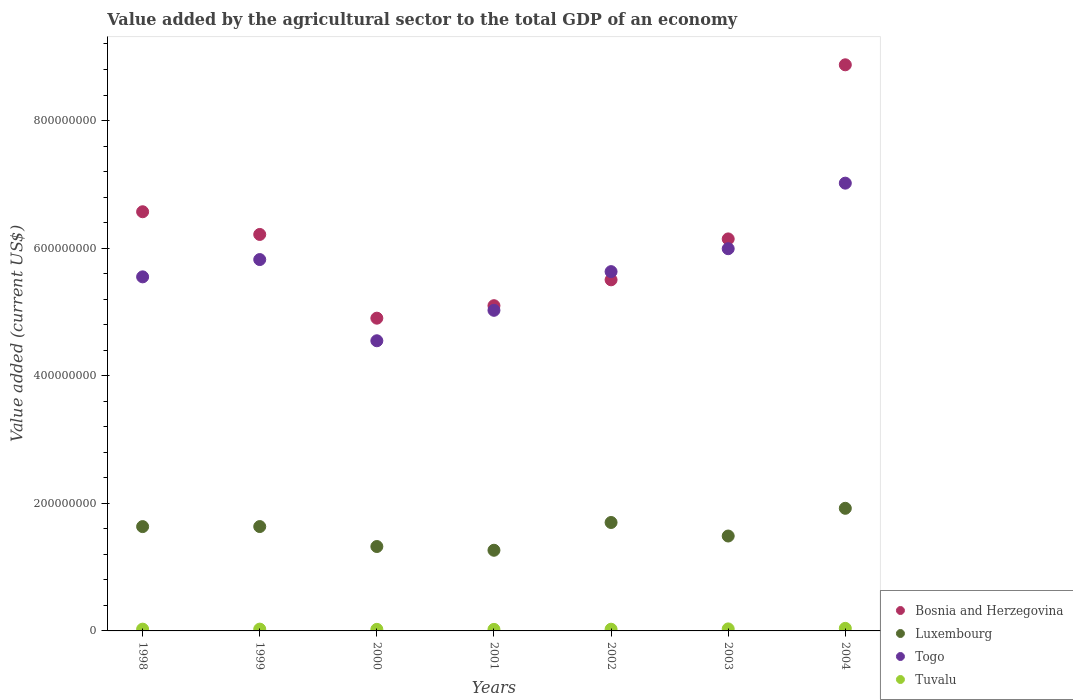What is the value added by the agricultural sector to the total GDP in Luxembourg in 2001?
Keep it short and to the point. 1.26e+08. Across all years, what is the maximum value added by the agricultural sector to the total GDP in Luxembourg?
Provide a short and direct response. 1.92e+08. Across all years, what is the minimum value added by the agricultural sector to the total GDP in Bosnia and Herzegovina?
Keep it short and to the point. 4.90e+08. In which year was the value added by the agricultural sector to the total GDP in Bosnia and Herzegovina maximum?
Provide a succinct answer. 2004. In which year was the value added by the agricultural sector to the total GDP in Bosnia and Herzegovina minimum?
Keep it short and to the point. 2000. What is the total value added by the agricultural sector to the total GDP in Bosnia and Herzegovina in the graph?
Make the answer very short. 4.33e+09. What is the difference between the value added by the agricultural sector to the total GDP in Bosnia and Herzegovina in 1998 and that in 1999?
Your response must be concise. 3.56e+07. What is the difference between the value added by the agricultural sector to the total GDP in Luxembourg in 1998 and the value added by the agricultural sector to the total GDP in Togo in 2002?
Give a very brief answer. -4.00e+08. What is the average value added by the agricultural sector to the total GDP in Tuvalu per year?
Give a very brief answer. 2.91e+06. In the year 2004, what is the difference between the value added by the agricultural sector to the total GDP in Tuvalu and value added by the agricultural sector to the total GDP in Bosnia and Herzegovina?
Your response must be concise. -8.83e+08. What is the ratio of the value added by the agricultural sector to the total GDP in Tuvalu in 1999 to that in 2001?
Offer a terse response. 1.17. Is the value added by the agricultural sector to the total GDP in Luxembourg in 1999 less than that in 2001?
Provide a short and direct response. No. Is the difference between the value added by the agricultural sector to the total GDP in Tuvalu in 1999 and 2000 greater than the difference between the value added by the agricultural sector to the total GDP in Bosnia and Herzegovina in 1999 and 2000?
Ensure brevity in your answer.  No. What is the difference between the highest and the second highest value added by the agricultural sector to the total GDP in Tuvalu?
Offer a very short reply. 8.54e+05. What is the difference between the highest and the lowest value added by the agricultural sector to the total GDP in Luxembourg?
Your answer should be compact. 6.58e+07. In how many years, is the value added by the agricultural sector to the total GDP in Bosnia and Herzegovina greater than the average value added by the agricultural sector to the total GDP in Bosnia and Herzegovina taken over all years?
Provide a short and direct response. 3. Is the sum of the value added by the agricultural sector to the total GDP in Luxembourg in 1999 and 2000 greater than the maximum value added by the agricultural sector to the total GDP in Togo across all years?
Your answer should be very brief. No. Is it the case that in every year, the sum of the value added by the agricultural sector to the total GDP in Togo and value added by the agricultural sector to the total GDP in Luxembourg  is greater than the sum of value added by the agricultural sector to the total GDP in Bosnia and Herzegovina and value added by the agricultural sector to the total GDP in Tuvalu?
Keep it short and to the point. No. Is it the case that in every year, the sum of the value added by the agricultural sector to the total GDP in Bosnia and Herzegovina and value added by the agricultural sector to the total GDP in Tuvalu  is greater than the value added by the agricultural sector to the total GDP in Luxembourg?
Ensure brevity in your answer.  Yes. Is the value added by the agricultural sector to the total GDP in Tuvalu strictly greater than the value added by the agricultural sector to the total GDP in Togo over the years?
Your answer should be very brief. No. Is the value added by the agricultural sector to the total GDP in Tuvalu strictly less than the value added by the agricultural sector to the total GDP in Bosnia and Herzegovina over the years?
Your response must be concise. Yes. How many dotlines are there?
Your response must be concise. 4. How many years are there in the graph?
Your answer should be very brief. 7. What is the difference between two consecutive major ticks on the Y-axis?
Give a very brief answer. 2.00e+08. Are the values on the major ticks of Y-axis written in scientific E-notation?
Make the answer very short. No. Does the graph contain grids?
Provide a succinct answer. No. How are the legend labels stacked?
Provide a succinct answer. Vertical. What is the title of the graph?
Give a very brief answer. Value added by the agricultural sector to the total GDP of an economy. Does "Cabo Verde" appear as one of the legend labels in the graph?
Your answer should be very brief. No. What is the label or title of the Y-axis?
Your answer should be compact. Value added (current US$). What is the Value added (current US$) in Bosnia and Herzegovina in 1998?
Give a very brief answer. 6.57e+08. What is the Value added (current US$) in Luxembourg in 1998?
Provide a succinct answer. 1.64e+08. What is the Value added (current US$) of Togo in 1998?
Offer a very short reply. 5.55e+08. What is the Value added (current US$) of Tuvalu in 1998?
Provide a succinct answer. 2.78e+06. What is the Value added (current US$) in Bosnia and Herzegovina in 1999?
Ensure brevity in your answer.  6.21e+08. What is the Value added (current US$) of Luxembourg in 1999?
Your answer should be very brief. 1.64e+08. What is the Value added (current US$) in Togo in 1999?
Your answer should be very brief. 5.82e+08. What is the Value added (current US$) in Tuvalu in 1999?
Your answer should be very brief. 2.83e+06. What is the Value added (current US$) of Bosnia and Herzegovina in 2000?
Offer a very short reply. 4.90e+08. What is the Value added (current US$) in Luxembourg in 2000?
Your answer should be compact. 1.32e+08. What is the Value added (current US$) of Togo in 2000?
Provide a succinct answer. 4.55e+08. What is the Value added (current US$) of Tuvalu in 2000?
Your answer should be compact. 2.46e+06. What is the Value added (current US$) of Bosnia and Herzegovina in 2001?
Offer a terse response. 5.10e+08. What is the Value added (current US$) in Luxembourg in 2001?
Provide a succinct answer. 1.26e+08. What is the Value added (current US$) of Togo in 2001?
Make the answer very short. 5.03e+08. What is the Value added (current US$) in Tuvalu in 2001?
Keep it short and to the point. 2.42e+06. What is the Value added (current US$) in Bosnia and Herzegovina in 2002?
Offer a terse response. 5.50e+08. What is the Value added (current US$) of Luxembourg in 2002?
Offer a very short reply. 1.70e+08. What is the Value added (current US$) in Togo in 2002?
Give a very brief answer. 5.63e+08. What is the Value added (current US$) of Tuvalu in 2002?
Make the answer very short. 2.69e+06. What is the Value added (current US$) in Bosnia and Herzegovina in 2003?
Your response must be concise. 6.14e+08. What is the Value added (current US$) in Luxembourg in 2003?
Ensure brevity in your answer.  1.49e+08. What is the Value added (current US$) in Togo in 2003?
Ensure brevity in your answer.  5.99e+08. What is the Value added (current US$) in Tuvalu in 2003?
Your answer should be very brief. 3.17e+06. What is the Value added (current US$) in Bosnia and Herzegovina in 2004?
Provide a succinct answer. 8.87e+08. What is the Value added (current US$) in Luxembourg in 2004?
Offer a very short reply. 1.92e+08. What is the Value added (current US$) of Togo in 2004?
Ensure brevity in your answer.  7.02e+08. What is the Value added (current US$) in Tuvalu in 2004?
Provide a short and direct response. 4.02e+06. Across all years, what is the maximum Value added (current US$) of Bosnia and Herzegovina?
Provide a succinct answer. 8.87e+08. Across all years, what is the maximum Value added (current US$) of Luxembourg?
Offer a very short reply. 1.92e+08. Across all years, what is the maximum Value added (current US$) of Togo?
Offer a very short reply. 7.02e+08. Across all years, what is the maximum Value added (current US$) in Tuvalu?
Provide a short and direct response. 4.02e+06. Across all years, what is the minimum Value added (current US$) of Bosnia and Herzegovina?
Ensure brevity in your answer.  4.90e+08. Across all years, what is the minimum Value added (current US$) in Luxembourg?
Your answer should be very brief. 1.26e+08. Across all years, what is the minimum Value added (current US$) in Togo?
Offer a very short reply. 4.55e+08. Across all years, what is the minimum Value added (current US$) of Tuvalu?
Offer a very short reply. 2.42e+06. What is the total Value added (current US$) in Bosnia and Herzegovina in the graph?
Keep it short and to the point. 4.33e+09. What is the total Value added (current US$) of Luxembourg in the graph?
Provide a short and direct response. 1.10e+09. What is the total Value added (current US$) in Togo in the graph?
Your answer should be very brief. 3.96e+09. What is the total Value added (current US$) in Tuvalu in the graph?
Provide a succinct answer. 2.04e+07. What is the difference between the Value added (current US$) of Bosnia and Herzegovina in 1998 and that in 1999?
Your response must be concise. 3.56e+07. What is the difference between the Value added (current US$) of Luxembourg in 1998 and that in 1999?
Offer a very short reply. -7.59e+04. What is the difference between the Value added (current US$) in Togo in 1998 and that in 1999?
Provide a succinct answer. -2.71e+07. What is the difference between the Value added (current US$) of Tuvalu in 1998 and that in 1999?
Provide a short and direct response. -5.75e+04. What is the difference between the Value added (current US$) of Bosnia and Herzegovina in 1998 and that in 2000?
Offer a very short reply. 1.67e+08. What is the difference between the Value added (current US$) in Luxembourg in 1998 and that in 2000?
Your answer should be compact. 3.12e+07. What is the difference between the Value added (current US$) in Togo in 1998 and that in 2000?
Offer a terse response. 1.00e+08. What is the difference between the Value added (current US$) in Tuvalu in 1998 and that in 2000?
Ensure brevity in your answer.  3.14e+05. What is the difference between the Value added (current US$) of Bosnia and Herzegovina in 1998 and that in 2001?
Ensure brevity in your answer.  1.47e+08. What is the difference between the Value added (current US$) in Luxembourg in 1998 and that in 2001?
Your answer should be very brief. 3.71e+07. What is the difference between the Value added (current US$) in Togo in 1998 and that in 2001?
Give a very brief answer. 5.24e+07. What is the difference between the Value added (current US$) of Tuvalu in 1998 and that in 2001?
Offer a terse response. 3.61e+05. What is the difference between the Value added (current US$) in Bosnia and Herzegovina in 1998 and that in 2002?
Your answer should be very brief. 1.07e+08. What is the difference between the Value added (current US$) of Luxembourg in 1998 and that in 2002?
Ensure brevity in your answer.  -6.45e+06. What is the difference between the Value added (current US$) in Togo in 1998 and that in 2002?
Keep it short and to the point. -8.19e+06. What is the difference between the Value added (current US$) in Tuvalu in 1998 and that in 2002?
Keep it short and to the point. 9.21e+04. What is the difference between the Value added (current US$) in Bosnia and Herzegovina in 1998 and that in 2003?
Offer a very short reply. 4.26e+07. What is the difference between the Value added (current US$) in Luxembourg in 1998 and that in 2003?
Offer a terse response. 1.48e+07. What is the difference between the Value added (current US$) in Togo in 1998 and that in 2003?
Ensure brevity in your answer.  -4.41e+07. What is the difference between the Value added (current US$) in Tuvalu in 1998 and that in 2003?
Keep it short and to the point. -3.92e+05. What is the difference between the Value added (current US$) of Bosnia and Herzegovina in 1998 and that in 2004?
Provide a succinct answer. -2.30e+08. What is the difference between the Value added (current US$) in Luxembourg in 1998 and that in 2004?
Your response must be concise. -2.87e+07. What is the difference between the Value added (current US$) in Togo in 1998 and that in 2004?
Provide a short and direct response. -1.47e+08. What is the difference between the Value added (current US$) of Tuvalu in 1998 and that in 2004?
Make the answer very short. -1.25e+06. What is the difference between the Value added (current US$) of Bosnia and Herzegovina in 1999 and that in 2000?
Offer a terse response. 1.31e+08. What is the difference between the Value added (current US$) of Luxembourg in 1999 and that in 2000?
Offer a very short reply. 3.13e+07. What is the difference between the Value added (current US$) of Togo in 1999 and that in 2000?
Make the answer very short. 1.27e+08. What is the difference between the Value added (current US$) in Tuvalu in 1999 and that in 2000?
Offer a terse response. 3.72e+05. What is the difference between the Value added (current US$) in Bosnia and Herzegovina in 1999 and that in 2001?
Offer a very short reply. 1.12e+08. What is the difference between the Value added (current US$) in Luxembourg in 1999 and that in 2001?
Offer a terse response. 3.71e+07. What is the difference between the Value added (current US$) of Togo in 1999 and that in 2001?
Make the answer very short. 7.96e+07. What is the difference between the Value added (current US$) of Tuvalu in 1999 and that in 2001?
Offer a very short reply. 4.18e+05. What is the difference between the Value added (current US$) of Bosnia and Herzegovina in 1999 and that in 2002?
Ensure brevity in your answer.  7.11e+07. What is the difference between the Value added (current US$) of Luxembourg in 1999 and that in 2002?
Offer a very short reply. -6.37e+06. What is the difference between the Value added (current US$) of Togo in 1999 and that in 2002?
Provide a succinct answer. 1.89e+07. What is the difference between the Value added (current US$) of Tuvalu in 1999 and that in 2002?
Offer a very short reply. 1.50e+05. What is the difference between the Value added (current US$) in Bosnia and Herzegovina in 1999 and that in 2003?
Give a very brief answer. 7.01e+06. What is the difference between the Value added (current US$) of Luxembourg in 1999 and that in 2003?
Provide a short and direct response. 1.48e+07. What is the difference between the Value added (current US$) in Togo in 1999 and that in 2003?
Give a very brief answer. -1.70e+07. What is the difference between the Value added (current US$) in Tuvalu in 1999 and that in 2003?
Offer a terse response. -3.35e+05. What is the difference between the Value added (current US$) in Bosnia and Herzegovina in 1999 and that in 2004?
Keep it short and to the point. -2.66e+08. What is the difference between the Value added (current US$) in Luxembourg in 1999 and that in 2004?
Your answer should be compact. -2.86e+07. What is the difference between the Value added (current US$) of Togo in 1999 and that in 2004?
Provide a succinct answer. -1.20e+08. What is the difference between the Value added (current US$) in Tuvalu in 1999 and that in 2004?
Ensure brevity in your answer.  -1.19e+06. What is the difference between the Value added (current US$) in Bosnia and Herzegovina in 2000 and that in 2001?
Your answer should be compact. -1.96e+07. What is the difference between the Value added (current US$) of Luxembourg in 2000 and that in 2001?
Your answer should be very brief. 5.86e+06. What is the difference between the Value added (current US$) in Togo in 2000 and that in 2001?
Give a very brief answer. -4.77e+07. What is the difference between the Value added (current US$) in Tuvalu in 2000 and that in 2001?
Your response must be concise. 4.62e+04. What is the difference between the Value added (current US$) in Bosnia and Herzegovina in 2000 and that in 2002?
Provide a short and direct response. -6.01e+07. What is the difference between the Value added (current US$) of Luxembourg in 2000 and that in 2002?
Give a very brief answer. -3.77e+07. What is the difference between the Value added (current US$) in Togo in 2000 and that in 2002?
Your answer should be compact. -1.08e+08. What is the difference between the Value added (current US$) of Tuvalu in 2000 and that in 2002?
Ensure brevity in your answer.  -2.22e+05. What is the difference between the Value added (current US$) of Bosnia and Herzegovina in 2000 and that in 2003?
Offer a terse response. -1.24e+08. What is the difference between the Value added (current US$) in Luxembourg in 2000 and that in 2003?
Offer a very short reply. -1.65e+07. What is the difference between the Value added (current US$) in Togo in 2000 and that in 2003?
Provide a short and direct response. -1.44e+08. What is the difference between the Value added (current US$) in Tuvalu in 2000 and that in 2003?
Provide a short and direct response. -7.07e+05. What is the difference between the Value added (current US$) in Bosnia and Herzegovina in 2000 and that in 2004?
Your answer should be very brief. -3.97e+08. What is the difference between the Value added (current US$) of Luxembourg in 2000 and that in 2004?
Offer a very short reply. -5.99e+07. What is the difference between the Value added (current US$) of Togo in 2000 and that in 2004?
Offer a terse response. -2.47e+08. What is the difference between the Value added (current US$) of Tuvalu in 2000 and that in 2004?
Your answer should be very brief. -1.56e+06. What is the difference between the Value added (current US$) in Bosnia and Herzegovina in 2001 and that in 2002?
Offer a terse response. -4.05e+07. What is the difference between the Value added (current US$) in Luxembourg in 2001 and that in 2002?
Your response must be concise. -4.35e+07. What is the difference between the Value added (current US$) in Togo in 2001 and that in 2002?
Ensure brevity in your answer.  -6.06e+07. What is the difference between the Value added (current US$) of Tuvalu in 2001 and that in 2002?
Make the answer very short. -2.68e+05. What is the difference between the Value added (current US$) of Bosnia and Herzegovina in 2001 and that in 2003?
Provide a short and direct response. -1.05e+08. What is the difference between the Value added (current US$) of Luxembourg in 2001 and that in 2003?
Ensure brevity in your answer.  -2.23e+07. What is the difference between the Value added (current US$) of Togo in 2001 and that in 2003?
Your answer should be compact. -9.66e+07. What is the difference between the Value added (current US$) in Tuvalu in 2001 and that in 2003?
Provide a succinct answer. -7.53e+05. What is the difference between the Value added (current US$) in Bosnia and Herzegovina in 2001 and that in 2004?
Your answer should be compact. -3.78e+08. What is the difference between the Value added (current US$) of Luxembourg in 2001 and that in 2004?
Provide a succinct answer. -6.58e+07. What is the difference between the Value added (current US$) of Togo in 2001 and that in 2004?
Your response must be concise. -1.99e+08. What is the difference between the Value added (current US$) of Tuvalu in 2001 and that in 2004?
Your answer should be very brief. -1.61e+06. What is the difference between the Value added (current US$) of Bosnia and Herzegovina in 2002 and that in 2003?
Make the answer very short. -6.41e+07. What is the difference between the Value added (current US$) of Luxembourg in 2002 and that in 2003?
Offer a terse response. 2.12e+07. What is the difference between the Value added (current US$) in Togo in 2002 and that in 2003?
Your answer should be very brief. -3.59e+07. What is the difference between the Value added (current US$) in Tuvalu in 2002 and that in 2003?
Make the answer very short. -4.84e+05. What is the difference between the Value added (current US$) of Bosnia and Herzegovina in 2002 and that in 2004?
Offer a terse response. -3.37e+08. What is the difference between the Value added (current US$) of Luxembourg in 2002 and that in 2004?
Make the answer very short. -2.22e+07. What is the difference between the Value added (current US$) of Togo in 2002 and that in 2004?
Your answer should be very brief. -1.39e+08. What is the difference between the Value added (current US$) of Tuvalu in 2002 and that in 2004?
Keep it short and to the point. -1.34e+06. What is the difference between the Value added (current US$) in Bosnia and Herzegovina in 2003 and that in 2004?
Give a very brief answer. -2.73e+08. What is the difference between the Value added (current US$) of Luxembourg in 2003 and that in 2004?
Provide a short and direct response. -4.34e+07. What is the difference between the Value added (current US$) of Togo in 2003 and that in 2004?
Offer a very short reply. -1.03e+08. What is the difference between the Value added (current US$) in Tuvalu in 2003 and that in 2004?
Make the answer very short. -8.54e+05. What is the difference between the Value added (current US$) of Bosnia and Herzegovina in 1998 and the Value added (current US$) of Luxembourg in 1999?
Give a very brief answer. 4.93e+08. What is the difference between the Value added (current US$) of Bosnia and Herzegovina in 1998 and the Value added (current US$) of Togo in 1999?
Keep it short and to the point. 7.49e+07. What is the difference between the Value added (current US$) in Bosnia and Herzegovina in 1998 and the Value added (current US$) in Tuvalu in 1999?
Keep it short and to the point. 6.54e+08. What is the difference between the Value added (current US$) in Luxembourg in 1998 and the Value added (current US$) in Togo in 1999?
Make the answer very short. -4.19e+08. What is the difference between the Value added (current US$) in Luxembourg in 1998 and the Value added (current US$) in Tuvalu in 1999?
Ensure brevity in your answer.  1.61e+08. What is the difference between the Value added (current US$) of Togo in 1998 and the Value added (current US$) of Tuvalu in 1999?
Provide a succinct answer. 5.52e+08. What is the difference between the Value added (current US$) of Bosnia and Herzegovina in 1998 and the Value added (current US$) of Luxembourg in 2000?
Offer a terse response. 5.25e+08. What is the difference between the Value added (current US$) in Bosnia and Herzegovina in 1998 and the Value added (current US$) in Togo in 2000?
Make the answer very short. 2.02e+08. What is the difference between the Value added (current US$) of Bosnia and Herzegovina in 1998 and the Value added (current US$) of Tuvalu in 2000?
Ensure brevity in your answer.  6.55e+08. What is the difference between the Value added (current US$) of Luxembourg in 1998 and the Value added (current US$) of Togo in 2000?
Keep it short and to the point. -2.91e+08. What is the difference between the Value added (current US$) of Luxembourg in 1998 and the Value added (current US$) of Tuvalu in 2000?
Your answer should be very brief. 1.61e+08. What is the difference between the Value added (current US$) of Togo in 1998 and the Value added (current US$) of Tuvalu in 2000?
Your answer should be very brief. 5.53e+08. What is the difference between the Value added (current US$) of Bosnia and Herzegovina in 1998 and the Value added (current US$) of Luxembourg in 2001?
Make the answer very short. 5.31e+08. What is the difference between the Value added (current US$) of Bosnia and Herzegovina in 1998 and the Value added (current US$) of Togo in 2001?
Offer a very short reply. 1.54e+08. What is the difference between the Value added (current US$) of Bosnia and Herzegovina in 1998 and the Value added (current US$) of Tuvalu in 2001?
Give a very brief answer. 6.55e+08. What is the difference between the Value added (current US$) of Luxembourg in 1998 and the Value added (current US$) of Togo in 2001?
Provide a short and direct response. -3.39e+08. What is the difference between the Value added (current US$) of Luxembourg in 1998 and the Value added (current US$) of Tuvalu in 2001?
Offer a terse response. 1.61e+08. What is the difference between the Value added (current US$) of Togo in 1998 and the Value added (current US$) of Tuvalu in 2001?
Keep it short and to the point. 5.53e+08. What is the difference between the Value added (current US$) in Bosnia and Herzegovina in 1998 and the Value added (current US$) in Luxembourg in 2002?
Your response must be concise. 4.87e+08. What is the difference between the Value added (current US$) in Bosnia and Herzegovina in 1998 and the Value added (current US$) in Togo in 2002?
Offer a very short reply. 9.39e+07. What is the difference between the Value added (current US$) of Bosnia and Herzegovina in 1998 and the Value added (current US$) of Tuvalu in 2002?
Your answer should be very brief. 6.54e+08. What is the difference between the Value added (current US$) in Luxembourg in 1998 and the Value added (current US$) in Togo in 2002?
Your answer should be compact. -4.00e+08. What is the difference between the Value added (current US$) in Luxembourg in 1998 and the Value added (current US$) in Tuvalu in 2002?
Your answer should be very brief. 1.61e+08. What is the difference between the Value added (current US$) of Togo in 1998 and the Value added (current US$) of Tuvalu in 2002?
Offer a terse response. 5.52e+08. What is the difference between the Value added (current US$) of Bosnia and Herzegovina in 1998 and the Value added (current US$) of Luxembourg in 2003?
Offer a terse response. 5.08e+08. What is the difference between the Value added (current US$) of Bosnia and Herzegovina in 1998 and the Value added (current US$) of Togo in 2003?
Make the answer very short. 5.79e+07. What is the difference between the Value added (current US$) in Bosnia and Herzegovina in 1998 and the Value added (current US$) in Tuvalu in 2003?
Keep it short and to the point. 6.54e+08. What is the difference between the Value added (current US$) of Luxembourg in 1998 and the Value added (current US$) of Togo in 2003?
Ensure brevity in your answer.  -4.36e+08. What is the difference between the Value added (current US$) in Luxembourg in 1998 and the Value added (current US$) in Tuvalu in 2003?
Offer a very short reply. 1.60e+08. What is the difference between the Value added (current US$) of Togo in 1998 and the Value added (current US$) of Tuvalu in 2003?
Provide a succinct answer. 5.52e+08. What is the difference between the Value added (current US$) of Bosnia and Herzegovina in 1998 and the Value added (current US$) of Luxembourg in 2004?
Provide a succinct answer. 4.65e+08. What is the difference between the Value added (current US$) of Bosnia and Herzegovina in 1998 and the Value added (current US$) of Togo in 2004?
Provide a short and direct response. -4.48e+07. What is the difference between the Value added (current US$) in Bosnia and Herzegovina in 1998 and the Value added (current US$) in Tuvalu in 2004?
Give a very brief answer. 6.53e+08. What is the difference between the Value added (current US$) in Luxembourg in 1998 and the Value added (current US$) in Togo in 2004?
Ensure brevity in your answer.  -5.38e+08. What is the difference between the Value added (current US$) in Luxembourg in 1998 and the Value added (current US$) in Tuvalu in 2004?
Offer a terse response. 1.59e+08. What is the difference between the Value added (current US$) in Togo in 1998 and the Value added (current US$) in Tuvalu in 2004?
Ensure brevity in your answer.  5.51e+08. What is the difference between the Value added (current US$) of Bosnia and Herzegovina in 1999 and the Value added (current US$) of Luxembourg in 2000?
Make the answer very short. 4.89e+08. What is the difference between the Value added (current US$) of Bosnia and Herzegovina in 1999 and the Value added (current US$) of Togo in 2000?
Your answer should be very brief. 1.67e+08. What is the difference between the Value added (current US$) in Bosnia and Herzegovina in 1999 and the Value added (current US$) in Tuvalu in 2000?
Provide a succinct answer. 6.19e+08. What is the difference between the Value added (current US$) in Luxembourg in 1999 and the Value added (current US$) in Togo in 2000?
Give a very brief answer. -2.91e+08. What is the difference between the Value added (current US$) of Luxembourg in 1999 and the Value added (current US$) of Tuvalu in 2000?
Provide a short and direct response. 1.61e+08. What is the difference between the Value added (current US$) in Togo in 1999 and the Value added (current US$) in Tuvalu in 2000?
Your response must be concise. 5.80e+08. What is the difference between the Value added (current US$) in Bosnia and Herzegovina in 1999 and the Value added (current US$) in Luxembourg in 2001?
Ensure brevity in your answer.  4.95e+08. What is the difference between the Value added (current US$) of Bosnia and Herzegovina in 1999 and the Value added (current US$) of Togo in 2001?
Your answer should be very brief. 1.19e+08. What is the difference between the Value added (current US$) in Bosnia and Herzegovina in 1999 and the Value added (current US$) in Tuvalu in 2001?
Provide a succinct answer. 6.19e+08. What is the difference between the Value added (current US$) in Luxembourg in 1999 and the Value added (current US$) in Togo in 2001?
Provide a short and direct response. -3.39e+08. What is the difference between the Value added (current US$) in Luxembourg in 1999 and the Value added (current US$) in Tuvalu in 2001?
Provide a short and direct response. 1.61e+08. What is the difference between the Value added (current US$) in Togo in 1999 and the Value added (current US$) in Tuvalu in 2001?
Make the answer very short. 5.80e+08. What is the difference between the Value added (current US$) in Bosnia and Herzegovina in 1999 and the Value added (current US$) in Luxembourg in 2002?
Your answer should be compact. 4.52e+08. What is the difference between the Value added (current US$) of Bosnia and Herzegovina in 1999 and the Value added (current US$) of Togo in 2002?
Offer a very short reply. 5.83e+07. What is the difference between the Value added (current US$) of Bosnia and Herzegovina in 1999 and the Value added (current US$) of Tuvalu in 2002?
Your answer should be compact. 6.19e+08. What is the difference between the Value added (current US$) in Luxembourg in 1999 and the Value added (current US$) in Togo in 2002?
Offer a terse response. -4.00e+08. What is the difference between the Value added (current US$) in Luxembourg in 1999 and the Value added (current US$) in Tuvalu in 2002?
Ensure brevity in your answer.  1.61e+08. What is the difference between the Value added (current US$) of Togo in 1999 and the Value added (current US$) of Tuvalu in 2002?
Offer a very short reply. 5.79e+08. What is the difference between the Value added (current US$) of Bosnia and Herzegovina in 1999 and the Value added (current US$) of Luxembourg in 2003?
Provide a succinct answer. 4.73e+08. What is the difference between the Value added (current US$) of Bosnia and Herzegovina in 1999 and the Value added (current US$) of Togo in 2003?
Keep it short and to the point. 2.24e+07. What is the difference between the Value added (current US$) in Bosnia and Herzegovina in 1999 and the Value added (current US$) in Tuvalu in 2003?
Make the answer very short. 6.18e+08. What is the difference between the Value added (current US$) of Luxembourg in 1999 and the Value added (current US$) of Togo in 2003?
Make the answer very short. -4.36e+08. What is the difference between the Value added (current US$) of Luxembourg in 1999 and the Value added (current US$) of Tuvalu in 2003?
Keep it short and to the point. 1.60e+08. What is the difference between the Value added (current US$) in Togo in 1999 and the Value added (current US$) in Tuvalu in 2003?
Your answer should be very brief. 5.79e+08. What is the difference between the Value added (current US$) in Bosnia and Herzegovina in 1999 and the Value added (current US$) in Luxembourg in 2004?
Provide a succinct answer. 4.29e+08. What is the difference between the Value added (current US$) of Bosnia and Herzegovina in 1999 and the Value added (current US$) of Togo in 2004?
Provide a short and direct response. -8.04e+07. What is the difference between the Value added (current US$) in Bosnia and Herzegovina in 1999 and the Value added (current US$) in Tuvalu in 2004?
Ensure brevity in your answer.  6.17e+08. What is the difference between the Value added (current US$) in Luxembourg in 1999 and the Value added (current US$) in Togo in 2004?
Ensure brevity in your answer.  -5.38e+08. What is the difference between the Value added (current US$) of Luxembourg in 1999 and the Value added (current US$) of Tuvalu in 2004?
Keep it short and to the point. 1.60e+08. What is the difference between the Value added (current US$) of Togo in 1999 and the Value added (current US$) of Tuvalu in 2004?
Your response must be concise. 5.78e+08. What is the difference between the Value added (current US$) in Bosnia and Herzegovina in 2000 and the Value added (current US$) in Luxembourg in 2001?
Your response must be concise. 3.64e+08. What is the difference between the Value added (current US$) in Bosnia and Herzegovina in 2000 and the Value added (current US$) in Togo in 2001?
Give a very brief answer. -1.23e+07. What is the difference between the Value added (current US$) of Bosnia and Herzegovina in 2000 and the Value added (current US$) of Tuvalu in 2001?
Your answer should be very brief. 4.88e+08. What is the difference between the Value added (current US$) of Luxembourg in 2000 and the Value added (current US$) of Togo in 2001?
Provide a short and direct response. -3.70e+08. What is the difference between the Value added (current US$) of Luxembourg in 2000 and the Value added (current US$) of Tuvalu in 2001?
Give a very brief answer. 1.30e+08. What is the difference between the Value added (current US$) in Togo in 2000 and the Value added (current US$) in Tuvalu in 2001?
Ensure brevity in your answer.  4.52e+08. What is the difference between the Value added (current US$) in Bosnia and Herzegovina in 2000 and the Value added (current US$) in Luxembourg in 2002?
Provide a succinct answer. 3.20e+08. What is the difference between the Value added (current US$) in Bosnia and Herzegovina in 2000 and the Value added (current US$) in Togo in 2002?
Provide a succinct answer. -7.30e+07. What is the difference between the Value added (current US$) of Bosnia and Herzegovina in 2000 and the Value added (current US$) of Tuvalu in 2002?
Make the answer very short. 4.88e+08. What is the difference between the Value added (current US$) of Luxembourg in 2000 and the Value added (current US$) of Togo in 2002?
Offer a terse response. -4.31e+08. What is the difference between the Value added (current US$) in Luxembourg in 2000 and the Value added (current US$) in Tuvalu in 2002?
Provide a succinct answer. 1.30e+08. What is the difference between the Value added (current US$) of Togo in 2000 and the Value added (current US$) of Tuvalu in 2002?
Provide a succinct answer. 4.52e+08. What is the difference between the Value added (current US$) of Bosnia and Herzegovina in 2000 and the Value added (current US$) of Luxembourg in 2003?
Provide a short and direct response. 3.41e+08. What is the difference between the Value added (current US$) of Bosnia and Herzegovina in 2000 and the Value added (current US$) of Togo in 2003?
Give a very brief answer. -1.09e+08. What is the difference between the Value added (current US$) in Bosnia and Herzegovina in 2000 and the Value added (current US$) in Tuvalu in 2003?
Give a very brief answer. 4.87e+08. What is the difference between the Value added (current US$) of Luxembourg in 2000 and the Value added (current US$) of Togo in 2003?
Your response must be concise. -4.67e+08. What is the difference between the Value added (current US$) in Luxembourg in 2000 and the Value added (current US$) in Tuvalu in 2003?
Your answer should be very brief. 1.29e+08. What is the difference between the Value added (current US$) in Togo in 2000 and the Value added (current US$) in Tuvalu in 2003?
Ensure brevity in your answer.  4.52e+08. What is the difference between the Value added (current US$) of Bosnia and Herzegovina in 2000 and the Value added (current US$) of Luxembourg in 2004?
Give a very brief answer. 2.98e+08. What is the difference between the Value added (current US$) in Bosnia and Herzegovina in 2000 and the Value added (current US$) in Togo in 2004?
Make the answer very short. -2.12e+08. What is the difference between the Value added (current US$) of Bosnia and Herzegovina in 2000 and the Value added (current US$) of Tuvalu in 2004?
Offer a terse response. 4.86e+08. What is the difference between the Value added (current US$) of Luxembourg in 2000 and the Value added (current US$) of Togo in 2004?
Keep it short and to the point. -5.70e+08. What is the difference between the Value added (current US$) in Luxembourg in 2000 and the Value added (current US$) in Tuvalu in 2004?
Keep it short and to the point. 1.28e+08. What is the difference between the Value added (current US$) in Togo in 2000 and the Value added (current US$) in Tuvalu in 2004?
Your answer should be compact. 4.51e+08. What is the difference between the Value added (current US$) of Bosnia and Herzegovina in 2001 and the Value added (current US$) of Luxembourg in 2002?
Provide a short and direct response. 3.40e+08. What is the difference between the Value added (current US$) of Bosnia and Herzegovina in 2001 and the Value added (current US$) of Togo in 2002?
Make the answer very short. -5.34e+07. What is the difference between the Value added (current US$) in Bosnia and Herzegovina in 2001 and the Value added (current US$) in Tuvalu in 2002?
Provide a short and direct response. 5.07e+08. What is the difference between the Value added (current US$) of Luxembourg in 2001 and the Value added (current US$) of Togo in 2002?
Provide a short and direct response. -4.37e+08. What is the difference between the Value added (current US$) in Luxembourg in 2001 and the Value added (current US$) in Tuvalu in 2002?
Your response must be concise. 1.24e+08. What is the difference between the Value added (current US$) in Togo in 2001 and the Value added (current US$) in Tuvalu in 2002?
Your answer should be compact. 5.00e+08. What is the difference between the Value added (current US$) in Bosnia and Herzegovina in 2001 and the Value added (current US$) in Luxembourg in 2003?
Your response must be concise. 3.61e+08. What is the difference between the Value added (current US$) of Bosnia and Herzegovina in 2001 and the Value added (current US$) of Togo in 2003?
Provide a short and direct response. -8.93e+07. What is the difference between the Value added (current US$) of Bosnia and Herzegovina in 2001 and the Value added (current US$) of Tuvalu in 2003?
Keep it short and to the point. 5.07e+08. What is the difference between the Value added (current US$) of Luxembourg in 2001 and the Value added (current US$) of Togo in 2003?
Your answer should be very brief. -4.73e+08. What is the difference between the Value added (current US$) of Luxembourg in 2001 and the Value added (current US$) of Tuvalu in 2003?
Your answer should be compact. 1.23e+08. What is the difference between the Value added (current US$) of Togo in 2001 and the Value added (current US$) of Tuvalu in 2003?
Provide a short and direct response. 4.99e+08. What is the difference between the Value added (current US$) in Bosnia and Herzegovina in 2001 and the Value added (current US$) in Luxembourg in 2004?
Provide a short and direct response. 3.18e+08. What is the difference between the Value added (current US$) of Bosnia and Herzegovina in 2001 and the Value added (current US$) of Togo in 2004?
Keep it short and to the point. -1.92e+08. What is the difference between the Value added (current US$) in Bosnia and Herzegovina in 2001 and the Value added (current US$) in Tuvalu in 2004?
Offer a very short reply. 5.06e+08. What is the difference between the Value added (current US$) of Luxembourg in 2001 and the Value added (current US$) of Togo in 2004?
Offer a very short reply. -5.75e+08. What is the difference between the Value added (current US$) in Luxembourg in 2001 and the Value added (current US$) in Tuvalu in 2004?
Provide a short and direct response. 1.22e+08. What is the difference between the Value added (current US$) of Togo in 2001 and the Value added (current US$) of Tuvalu in 2004?
Keep it short and to the point. 4.99e+08. What is the difference between the Value added (current US$) in Bosnia and Herzegovina in 2002 and the Value added (current US$) in Luxembourg in 2003?
Give a very brief answer. 4.02e+08. What is the difference between the Value added (current US$) of Bosnia and Herzegovina in 2002 and the Value added (current US$) of Togo in 2003?
Your answer should be compact. -4.88e+07. What is the difference between the Value added (current US$) in Bosnia and Herzegovina in 2002 and the Value added (current US$) in Tuvalu in 2003?
Make the answer very short. 5.47e+08. What is the difference between the Value added (current US$) of Luxembourg in 2002 and the Value added (current US$) of Togo in 2003?
Your response must be concise. -4.29e+08. What is the difference between the Value added (current US$) in Luxembourg in 2002 and the Value added (current US$) in Tuvalu in 2003?
Offer a very short reply. 1.67e+08. What is the difference between the Value added (current US$) in Togo in 2002 and the Value added (current US$) in Tuvalu in 2003?
Provide a short and direct response. 5.60e+08. What is the difference between the Value added (current US$) of Bosnia and Herzegovina in 2002 and the Value added (current US$) of Luxembourg in 2004?
Your answer should be compact. 3.58e+08. What is the difference between the Value added (current US$) of Bosnia and Herzegovina in 2002 and the Value added (current US$) of Togo in 2004?
Provide a succinct answer. -1.52e+08. What is the difference between the Value added (current US$) in Bosnia and Herzegovina in 2002 and the Value added (current US$) in Tuvalu in 2004?
Offer a terse response. 5.46e+08. What is the difference between the Value added (current US$) of Luxembourg in 2002 and the Value added (current US$) of Togo in 2004?
Offer a very short reply. -5.32e+08. What is the difference between the Value added (current US$) in Luxembourg in 2002 and the Value added (current US$) in Tuvalu in 2004?
Make the answer very short. 1.66e+08. What is the difference between the Value added (current US$) in Togo in 2002 and the Value added (current US$) in Tuvalu in 2004?
Make the answer very short. 5.59e+08. What is the difference between the Value added (current US$) of Bosnia and Herzegovina in 2003 and the Value added (current US$) of Luxembourg in 2004?
Your response must be concise. 4.22e+08. What is the difference between the Value added (current US$) of Bosnia and Herzegovina in 2003 and the Value added (current US$) of Togo in 2004?
Provide a succinct answer. -8.74e+07. What is the difference between the Value added (current US$) of Bosnia and Herzegovina in 2003 and the Value added (current US$) of Tuvalu in 2004?
Ensure brevity in your answer.  6.10e+08. What is the difference between the Value added (current US$) in Luxembourg in 2003 and the Value added (current US$) in Togo in 2004?
Offer a very short reply. -5.53e+08. What is the difference between the Value added (current US$) in Luxembourg in 2003 and the Value added (current US$) in Tuvalu in 2004?
Your answer should be very brief. 1.45e+08. What is the difference between the Value added (current US$) in Togo in 2003 and the Value added (current US$) in Tuvalu in 2004?
Ensure brevity in your answer.  5.95e+08. What is the average Value added (current US$) in Bosnia and Herzegovina per year?
Your response must be concise. 6.19e+08. What is the average Value added (current US$) of Luxembourg per year?
Offer a terse response. 1.57e+08. What is the average Value added (current US$) of Togo per year?
Provide a short and direct response. 5.66e+08. What is the average Value added (current US$) of Tuvalu per year?
Make the answer very short. 2.91e+06. In the year 1998, what is the difference between the Value added (current US$) in Bosnia and Herzegovina and Value added (current US$) in Luxembourg?
Ensure brevity in your answer.  4.94e+08. In the year 1998, what is the difference between the Value added (current US$) of Bosnia and Herzegovina and Value added (current US$) of Togo?
Your answer should be very brief. 1.02e+08. In the year 1998, what is the difference between the Value added (current US$) in Bosnia and Herzegovina and Value added (current US$) in Tuvalu?
Your answer should be very brief. 6.54e+08. In the year 1998, what is the difference between the Value added (current US$) of Luxembourg and Value added (current US$) of Togo?
Give a very brief answer. -3.91e+08. In the year 1998, what is the difference between the Value added (current US$) in Luxembourg and Value added (current US$) in Tuvalu?
Offer a terse response. 1.61e+08. In the year 1998, what is the difference between the Value added (current US$) of Togo and Value added (current US$) of Tuvalu?
Offer a very short reply. 5.52e+08. In the year 1999, what is the difference between the Value added (current US$) in Bosnia and Herzegovina and Value added (current US$) in Luxembourg?
Give a very brief answer. 4.58e+08. In the year 1999, what is the difference between the Value added (current US$) of Bosnia and Herzegovina and Value added (current US$) of Togo?
Provide a succinct answer. 3.94e+07. In the year 1999, what is the difference between the Value added (current US$) of Bosnia and Herzegovina and Value added (current US$) of Tuvalu?
Your response must be concise. 6.19e+08. In the year 1999, what is the difference between the Value added (current US$) in Luxembourg and Value added (current US$) in Togo?
Offer a terse response. -4.19e+08. In the year 1999, what is the difference between the Value added (current US$) of Luxembourg and Value added (current US$) of Tuvalu?
Keep it short and to the point. 1.61e+08. In the year 1999, what is the difference between the Value added (current US$) in Togo and Value added (current US$) in Tuvalu?
Your answer should be very brief. 5.79e+08. In the year 2000, what is the difference between the Value added (current US$) of Bosnia and Herzegovina and Value added (current US$) of Luxembourg?
Make the answer very short. 3.58e+08. In the year 2000, what is the difference between the Value added (current US$) in Bosnia and Herzegovina and Value added (current US$) in Togo?
Give a very brief answer. 3.54e+07. In the year 2000, what is the difference between the Value added (current US$) in Bosnia and Herzegovina and Value added (current US$) in Tuvalu?
Offer a very short reply. 4.88e+08. In the year 2000, what is the difference between the Value added (current US$) of Luxembourg and Value added (current US$) of Togo?
Your answer should be very brief. -3.23e+08. In the year 2000, what is the difference between the Value added (current US$) in Luxembourg and Value added (current US$) in Tuvalu?
Ensure brevity in your answer.  1.30e+08. In the year 2000, what is the difference between the Value added (current US$) of Togo and Value added (current US$) of Tuvalu?
Provide a short and direct response. 4.52e+08. In the year 2001, what is the difference between the Value added (current US$) in Bosnia and Herzegovina and Value added (current US$) in Luxembourg?
Offer a very short reply. 3.83e+08. In the year 2001, what is the difference between the Value added (current US$) in Bosnia and Herzegovina and Value added (current US$) in Togo?
Offer a very short reply. 7.25e+06. In the year 2001, what is the difference between the Value added (current US$) in Bosnia and Herzegovina and Value added (current US$) in Tuvalu?
Give a very brief answer. 5.07e+08. In the year 2001, what is the difference between the Value added (current US$) in Luxembourg and Value added (current US$) in Togo?
Provide a succinct answer. -3.76e+08. In the year 2001, what is the difference between the Value added (current US$) in Luxembourg and Value added (current US$) in Tuvalu?
Offer a very short reply. 1.24e+08. In the year 2001, what is the difference between the Value added (current US$) in Togo and Value added (current US$) in Tuvalu?
Provide a succinct answer. 5.00e+08. In the year 2002, what is the difference between the Value added (current US$) in Bosnia and Herzegovina and Value added (current US$) in Luxembourg?
Your answer should be very brief. 3.80e+08. In the year 2002, what is the difference between the Value added (current US$) in Bosnia and Herzegovina and Value added (current US$) in Togo?
Provide a short and direct response. -1.29e+07. In the year 2002, what is the difference between the Value added (current US$) of Bosnia and Herzegovina and Value added (current US$) of Tuvalu?
Ensure brevity in your answer.  5.48e+08. In the year 2002, what is the difference between the Value added (current US$) in Luxembourg and Value added (current US$) in Togo?
Your answer should be very brief. -3.93e+08. In the year 2002, what is the difference between the Value added (current US$) in Luxembourg and Value added (current US$) in Tuvalu?
Your answer should be very brief. 1.67e+08. In the year 2002, what is the difference between the Value added (current US$) of Togo and Value added (current US$) of Tuvalu?
Offer a very short reply. 5.61e+08. In the year 2003, what is the difference between the Value added (current US$) of Bosnia and Herzegovina and Value added (current US$) of Luxembourg?
Provide a short and direct response. 4.66e+08. In the year 2003, what is the difference between the Value added (current US$) of Bosnia and Herzegovina and Value added (current US$) of Togo?
Your answer should be compact. 1.54e+07. In the year 2003, what is the difference between the Value added (current US$) of Bosnia and Herzegovina and Value added (current US$) of Tuvalu?
Your answer should be compact. 6.11e+08. In the year 2003, what is the difference between the Value added (current US$) of Luxembourg and Value added (current US$) of Togo?
Give a very brief answer. -4.50e+08. In the year 2003, what is the difference between the Value added (current US$) in Luxembourg and Value added (current US$) in Tuvalu?
Ensure brevity in your answer.  1.46e+08. In the year 2003, what is the difference between the Value added (current US$) of Togo and Value added (current US$) of Tuvalu?
Provide a succinct answer. 5.96e+08. In the year 2004, what is the difference between the Value added (current US$) in Bosnia and Herzegovina and Value added (current US$) in Luxembourg?
Provide a short and direct response. 6.95e+08. In the year 2004, what is the difference between the Value added (current US$) of Bosnia and Herzegovina and Value added (current US$) of Togo?
Give a very brief answer. 1.86e+08. In the year 2004, what is the difference between the Value added (current US$) of Bosnia and Herzegovina and Value added (current US$) of Tuvalu?
Give a very brief answer. 8.83e+08. In the year 2004, what is the difference between the Value added (current US$) of Luxembourg and Value added (current US$) of Togo?
Keep it short and to the point. -5.10e+08. In the year 2004, what is the difference between the Value added (current US$) in Luxembourg and Value added (current US$) in Tuvalu?
Your answer should be compact. 1.88e+08. In the year 2004, what is the difference between the Value added (current US$) of Togo and Value added (current US$) of Tuvalu?
Your answer should be compact. 6.98e+08. What is the ratio of the Value added (current US$) of Bosnia and Herzegovina in 1998 to that in 1999?
Give a very brief answer. 1.06. What is the ratio of the Value added (current US$) of Togo in 1998 to that in 1999?
Offer a terse response. 0.95. What is the ratio of the Value added (current US$) in Tuvalu in 1998 to that in 1999?
Give a very brief answer. 0.98. What is the ratio of the Value added (current US$) of Bosnia and Herzegovina in 1998 to that in 2000?
Ensure brevity in your answer.  1.34. What is the ratio of the Value added (current US$) of Luxembourg in 1998 to that in 2000?
Ensure brevity in your answer.  1.24. What is the ratio of the Value added (current US$) in Togo in 1998 to that in 2000?
Provide a short and direct response. 1.22. What is the ratio of the Value added (current US$) in Tuvalu in 1998 to that in 2000?
Make the answer very short. 1.13. What is the ratio of the Value added (current US$) of Bosnia and Herzegovina in 1998 to that in 2001?
Ensure brevity in your answer.  1.29. What is the ratio of the Value added (current US$) of Luxembourg in 1998 to that in 2001?
Keep it short and to the point. 1.29. What is the ratio of the Value added (current US$) of Togo in 1998 to that in 2001?
Provide a short and direct response. 1.1. What is the ratio of the Value added (current US$) in Tuvalu in 1998 to that in 2001?
Give a very brief answer. 1.15. What is the ratio of the Value added (current US$) of Bosnia and Herzegovina in 1998 to that in 2002?
Your answer should be very brief. 1.19. What is the ratio of the Value added (current US$) in Luxembourg in 1998 to that in 2002?
Give a very brief answer. 0.96. What is the ratio of the Value added (current US$) in Togo in 1998 to that in 2002?
Keep it short and to the point. 0.99. What is the ratio of the Value added (current US$) of Tuvalu in 1998 to that in 2002?
Your answer should be very brief. 1.03. What is the ratio of the Value added (current US$) in Bosnia and Herzegovina in 1998 to that in 2003?
Give a very brief answer. 1.07. What is the ratio of the Value added (current US$) in Luxembourg in 1998 to that in 2003?
Your answer should be compact. 1.1. What is the ratio of the Value added (current US$) in Togo in 1998 to that in 2003?
Make the answer very short. 0.93. What is the ratio of the Value added (current US$) of Tuvalu in 1998 to that in 2003?
Keep it short and to the point. 0.88. What is the ratio of the Value added (current US$) of Bosnia and Herzegovina in 1998 to that in 2004?
Your answer should be very brief. 0.74. What is the ratio of the Value added (current US$) in Luxembourg in 1998 to that in 2004?
Your answer should be very brief. 0.85. What is the ratio of the Value added (current US$) of Togo in 1998 to that in 2004?
Your answer should be very brief. 0.79. What is the ratio of the Value added (current US$) of Tuvalu in 1998 to that in 2004?
Your answer should be very brief. 0.69. What is the ratio of the Value added (current US$) in Bosnia and Herzegovina in 1999 to that in 2000?
Make the answer very short. 1.27. What is the ratio of the Value added (current US$) in Luxembourg in 1999 to that in 2000?
Your response must be concise. 1.24. What is the ratio of the Value added (current US$) of Togo in 1999 to that in 2000?
Offer a very short reply. 1.28. What is the ratio of the Value added (current US$) in Tuvalu in 1999 to that in 2000?
Give a very brief answer. 1.15. What is the ratio of the Value added (current US$) in Bosnia and Herzegovina in 1999 to that in 2001?
Your answer should be compact. 1.22. What is the ratio of the Value added (current US$) of Luxembourg in 1999 to that in 2001?
Keep it short and to the point. 1.29. What is the ratio of the Value added (current US$) of Togo in 1999 to that in 2001?
Offer a very short reply. 1.16. What is the ratio of the Value added (current US$) of Tuvalu in 1999 to that in 2001?
Your answer should be very brief. 1.17. What is the ratio of the Value added (current US$) of Bosnia and Herzegovina in 1999 to that in 2002?
Offer a terse response. 1.13. What is the ratio of the Value added (current US$) of Luxembourg in 1999 to that in 2002?
Give a very brief answer. 0.96. What is the ratio of the Value added (current US$) in Togo in 1999 to that in 2002?
Your response must be concise. 1.03. What is the ratio of the Value added (current US$) of Tuvalu in 1999 to that in 2002?
Provide a succinct answer. 1.06. What is the ratio of the Value added (current US$) in Bosnia and Herzegovina in 1999 to that in 2003?
Offer a terse response. 1.01. What is the ratio of the Value added (current US$) of Luxembourg in 1999 to that in 2003?
Provide a succinct answer. 1.1. What is the ratio of the Value added (current US$) of Togo in 1999 to that in 2003?
Ensure brevity in your answer.  0.97. What is the ratio of the Value added (current US$) in Tuvalu in 1999 to that in 2003?
Give a very brief answer. 0.89. What is the ratio of the Value added (current US$) of Bosnia and Herzegovina in 1999 to that in 2004?
Your response must be concise. 0.7. What is the ratio of the Value added (current US$) in Luxembourg in 1999 to that in 2004?
Give a very brief answer. 0.85. What is the ratio of the Value added (current US$) of Togo in 1999 to that in 2004?
Provide a short and direct response. 0.83. What is the ratio of the Value added (current US$) of Tuvalu in 1999 to that in 2004?
Your answer should be compact. 0.7. What is the ratio of the Value added (current US$) in Bosnia and Herzegovina in 2000 to that in 2001?
Give a very brief answer. 0.96. What is the ratio of the Value added (current US$) of Luxembourg in 2000 to that in 2001?
Your response must be concise. 1.05. What is the ratio of the Value added (current US$) of Togo in 2000 to that in 2001?
Your response must be concise. 0.91. What is the ratio of the Value added (current US$) in Tuvalu in 2000 to that in 2001?
Keep it short and to the point. 1.02. What is the ratio of the Value added (current US$) of Bosnia and Herzegovina in 2000 to that in 2002?
Make the answer very short. 0.89. What is the ratio of the Value added (current US$) in Luxembourg in 2000 to that in 2002?
Your response must be concise. 0.78. What is the ratio of the Value added (current US$) of Togo in 2000 to that in 2002?
Your answer should be compact. 0.81. What is the ratio of the Value added (current US$) in Tuvalu in 2000 to that in 2002?
Offer a terse response. 0.92. What is the ratio of the Value added (current US$) of Bosnia and Herzegovina in 2000 to that in 2003?
Offer a terse response. 0.8. What is the ratio of the Value added (current US$) of Luxembourg in 2000 to that in 2003?
Make the answer very short. 0.89. What is the ratio of the Value added (current US$) in Togo in 2000 to that in 2003?
Offer a very short reply. 0.76. What is the ratio of the Value added (current US$) in Tuvalu in 2000 to that in 2003?
Offer a terse response. 0.78. What is the ratio of the Value added (current US$) of Bosnia and Herzegovina in 2000 to that in 2004?
Your answer should be compact. 0.55. What is the ratio of the Value added (current US$) of Luxembourg in 2000 to that in 2004?
Your response must be concise. 0.69. What is the ratio of the Value added (current US$) in Togo in 2000 to that in 2004?
Provide a succinct answer. 0.65. What is the ratio of the Value added (current US$) of Tuvalu in 2000 to that in 2004?
Ensure brevity in your answer.  0.61. What is the ratio of the Value added (current US$) of Bosnia and Herzegovina in 2001 to that in 2002?
Your answer should be compact. 0.93. What is the ratio of the Value added (current US$) of Luxembourg in 2001 to that in 2002?
Your answer should be very brief. 0.74. What is the ratio of the Value added (current US$) in Togo in 2001 to that in 2002?
Give a very brief answer. 0.89. What is the ratio of the Value added (current US$) of Bosnia and Herzegovina in 2001 to that in 2003?
Provide a succinct answer. 0.83. What is the ratio of the Value added (current US$) of Togo in 2001 to that in 2003?
Ensure brevity in your answer.  0.84. What is the ratio of the Value added (current US$) in Tuvalu in 2001 to that in 2003?
Provide a succinct answer. 0.76. What is the ratio of the Value added (current US$) in Bosnia and Herzegovina in 2001 to that in 2004?
Make the answer very short. 0.57. What is the ratio of the Value added (current US$) of Luxembourg in 2001 to that in 2004?
Your response must be concise. 0.66. What is the ratio of the Value added (current US$) in Togo in 2001 to that in 2004?
Offer a very short reply. 0.72. What is the ratio of the Value added (current US$) in Tuvalu in 2001 to that in 2004?
Keep it short and to the point. 0.6. What is the ratio of the Value added (current US$) of Bosnia and Herzegovina in 2002 to that in 2003?
Keep it short and to the point. 0.9. What is the ratio of the Value added (current US$) in Luxembourg in 2002 to that in 2003?
Offer a very short reply. 1.14. What is the ratio of the Value added (current US$) of Tuvalu in 2002 to that in 2003?
Offer a very short reply. 0.85. What is the ratio of the Value added (current US$) in Bosnia and Herzegovina in 2002 to that in 2004?
Offer a very short reply. 0.62. What is the ratio of the Value added (current US$) in Luxembourg in 2002 to that in 2004?
Make the answer very short. 0.88. What is the ratio of the Value added (current US$) of Togo in 2002 to that in 2004?
Your answer should be very brief. 0.8. What is the ratio of the Value added (current US$) in Tuvalu in 2002 to that in 2004?
Provide a succinct answer. 0.67. What is the ratio of the Value added (current US$) of Bosnia and Herzegovina in 2003 to that in 2004?
Give a very brief answer. 0.69. What is the ratio of the Value added (current US$) in Luxembourg in 2003 to that in 2004?
Provide a short and direct response. 0.77. What is the ratio of the Value added (current US$) of Togo in 2003 to that in 2004?
Ensure brevity in your answer.  0.85. What is the ratio of the Value added (current US$) of Tuvalu in 2003 to that in 2004?
Your answer should be compact. 0.79. What is the difference between the highest and the second highest Value added (current US$) in Bosnia and Herzegovina?
Offer a terse response. 2.30e+08. What is the difference between the highest and the second highest Value added (current US$) in Luxembourg?
Offer a very short reply. 2.22e+07. What is the difference between the highest and the second highest Value added (current US$) of Togo?
Your answer should be compact. 1.03e+08. What is the difference between the highest and the second highest Value added (current US$) in Tuvalu?
Your answer should be very brief. 8.54e+05. What is the difference between the highest and the lowest Value added (current US$) of Bosnia and Herzegovina?
Give a very brief answer. 3.97e+08. What is the difference between the highest and the lowest Value added (current US$) in Luxembourg?
Ensure brevity in your answer.  6.58e+07. What is the difference between the highest and the lowest Value added (current US$) of Togo?
Keep it short and to the point. 2.47e+08. What is the difference between the highest and the lowest Value added (current US$) in Tuvalu?
Your answer should be very brief. 1.61e+06. 